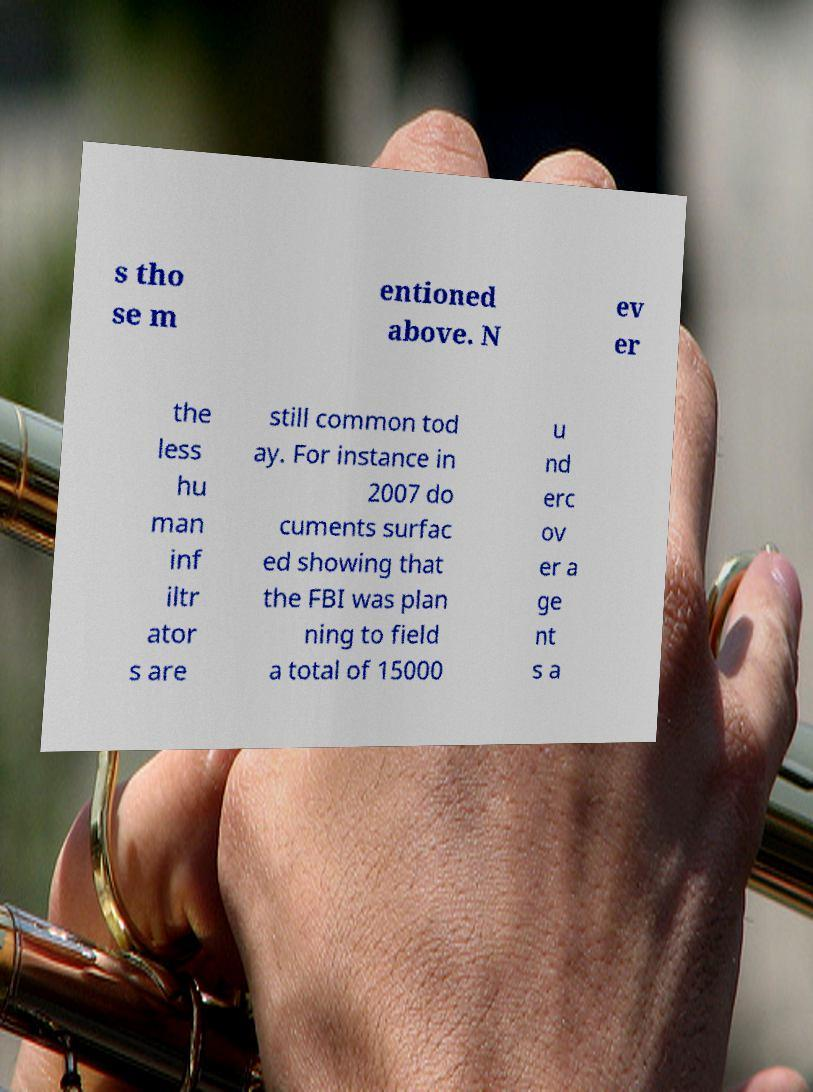I need the written content from this picture converted into text. Can you do that? s tho se m entioned above. N ev er the less hu man inf iltr ator s are still common tod ay. For instance in 2007 do cuments surfac ed showing that the FBI was plan ning to field a total of 15000 u nd erc ov er a ge nt s a 